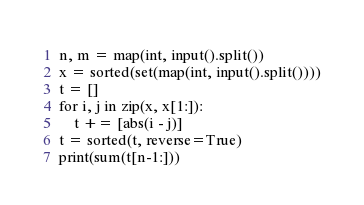<code> <loc_0><loc_0><loc_500><loc_500><_Python_>n, m = map(int, input().split())
x = sorted(set(map(int, input().split())))
t = []
for i, j in zip(x, x[1:]):
    t += [abs(i - j)]
t = sorted(t, reverse=True)
print(sum(t[n-1:]))
</code> 